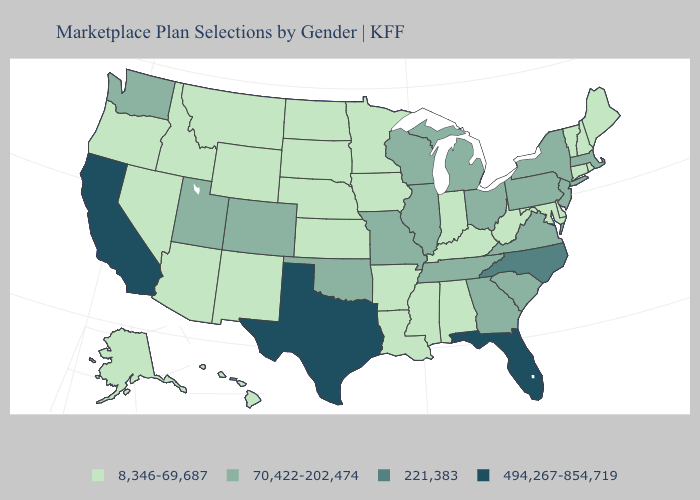Which states have the lowest value in the West?
Keep it brief. Alaska, Arizona, Hawaii, Idaho, Montana, Nevada, New Mexico, Oregon, Wyoming. Name the states that have a value in the range 221,383?
Be succinct. North Carolina. Does Oklahoma have the same value as Utah?
Keep it brief. Yes. Which states hav the highest value in the South?
Be succinct. Florida, Texas. Which states hav the highest value in the Northeast?
Concise answer only. Massachusetts, New Jersey, New York, Pennsylvania. What is the highest value in states that border Louisiana?
Write a very short answer. 494,267-854,719. How many symbols are there in the legend?
Write a very short answer. 4. Name the states that have a value in the range 70,422-202,474?
Give a very brief answer. Colorado, Georgia, Illinois, Massachusetts, Michigan, Missouri, New Jersey, New York, Ohio, Oklahoma, Pennsylvania, South Carolina, Tennessee, Utah, Virginia, Washington, Wisconsin. Does Idaho have the lowest value in the USA?
Write a very short answer. Yes. What is the value of Wyoming?
Short answer required. 8,346-69,687. Does the first symbol in the legend represent the smallest category?
Short answer required. Yes. Name the states that have a value in the range 494,267-854,719?
Be succinct. California, Florida, Texas. Name the states that have a value in the range 70,422-202,474?
Quick response, please. Colorado, Georgia, Illinois, Massachusetts, Michigan, Missouri, New Jersey, New York, Ohio, Oklahoma, Pennsylvania, South Carolina, Tennessee, Utah, Virginia, Washington, Wisconsin. Which states have the highest value in the USA?
Be succinct. California, Florida, Texas. Does Maryland have the highest value in the South?
Keep it brief. No. 